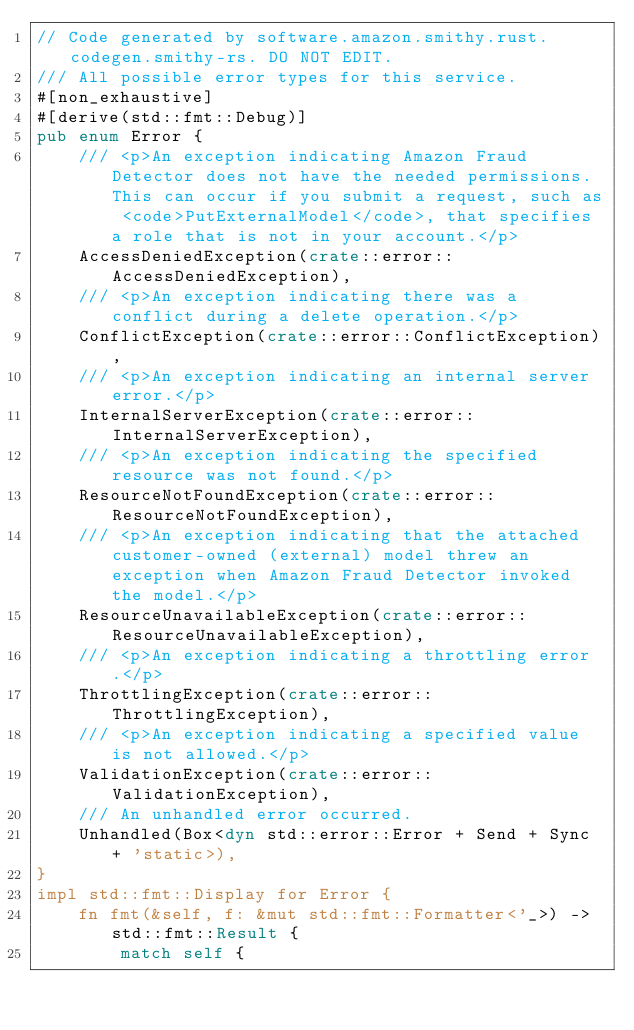Convert code to text. <code><loc_0><loc_0><loc_500><loc_500><_Rust_>// Code generated by software.amazon.smithy.rust.codegen.smithy-rs. DO NOT EDIT.
/// All possible error types for this service.
#[non_exhaustive]
#[derive(std::fmt::Debug)]
pub enum Error {
    /// <p>An exception indicating Amazon Fraud Detector does not have the needed permissions. This can occur if you submit a request, such as <code>PutExternalModel</code>, that specifies a role that is not in your account.</p>
    AccessDeniedException(crate::error::AccessDeniedException),
    /// <p>An exception indicating there was a conflict during a delete operation.</p>
    ConflictException(crate::error::ConflictException),
    /// <p>An exception indicating an internal server error.</p>
    InternalServerException(crate::error::InternalServerException),
    /// <p>An exception indicating the specified resource was not found.</p>
    ResourceNotFoundException(crate::error::ResourceNotFoundException),
    /// <p>An exception indicating that the attached customer-owned (external) model threw an exception when Amazon Fraud Detector invoked the model.</p>
    ResourceUnavailableException(crate::error::ResourceUnavailableException),
    /// <p>An exception indicating a throttling error.</p>
    ThrottlingException(crate::error::ThrottlingException),
    /// <p>An exception indicating a specified value is not allowed.</p>
    ValidationException(crate::error::ValidationException),
    /// An unhandled error occurred.
    Unhandled(Box<dyn std::error::Error + Send + Sync + 'static>),
}
impl std::fmt::Display for Error {
    fn fmt(&self, f: &mut std::fmt::Formatter<'_>) -> std::fmt::Result {
        match self {</code> 